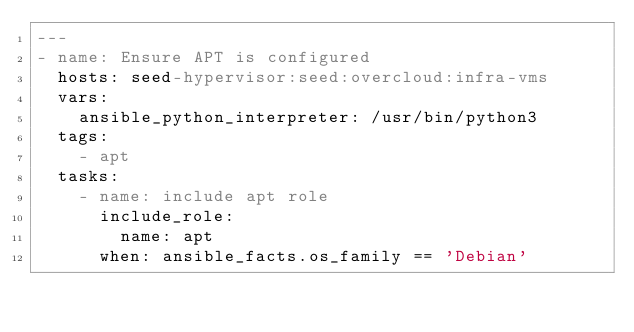<code> <loc_0><loc_0><loc_500><loc_500><_YAML_>---
- name: Ensure APT is configured
  hosts: seed-hypervisor:seed:overcloud:infra-vms
  vars:
    ansible_python_interpreter: /usr/bin/python3
  tags:
    - apt
  tasks:
    - name: include apt role
      include_role:
        name: apt
      when: ansible_facts.os_family == 'Debian'
</code> 